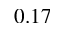Convert formula to latex. <formula><loc_0><loc_0><loc_500><loc_500>0 . 1 7</formula> 